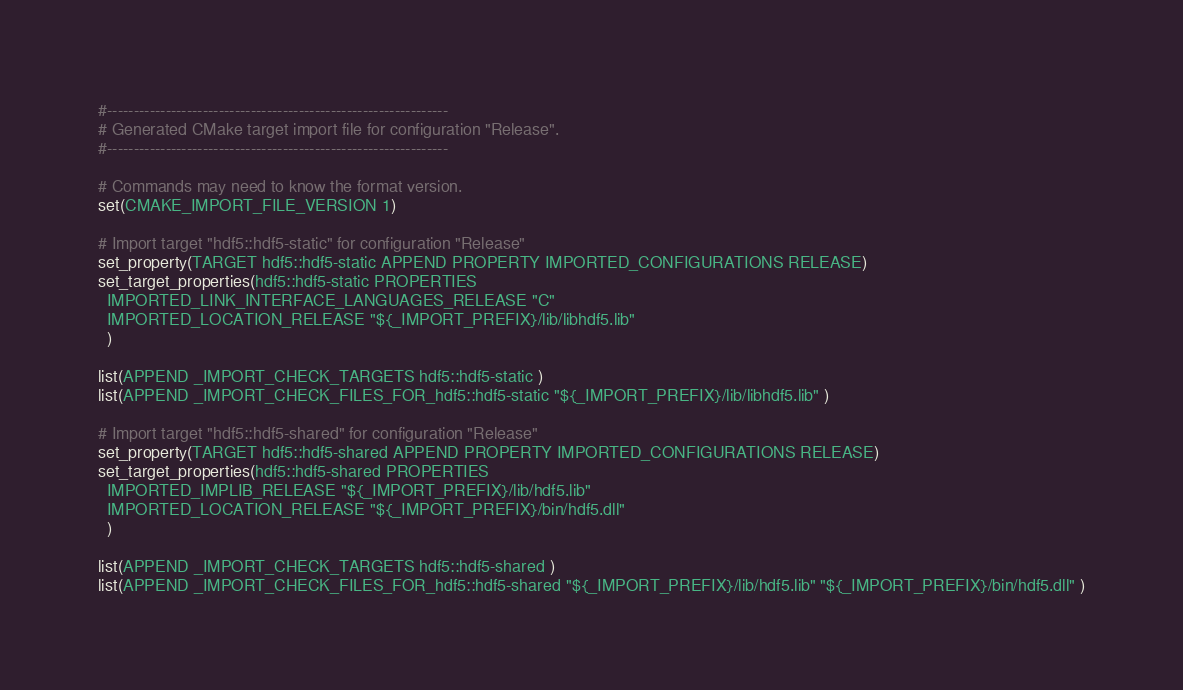Convert code to text. <code><loc_0><loc_0><loc_500><loc_500><_CMake_>#----------------------------------------------------------------
# Generated CMake target import file for configuration "Release".
#----------------------------------------------------------------

# Commands may need to know the format version.
set(CMAKE_IMPORT_FILE_VERSION 1)

# Import target "hdf5::hdf5-static" for configuration "Release"
set_property(TARGET hdf5::hdf5-static APPEND PROPERTY IMPORTED_CONFIGURATIONS RELEASE)
set_target_properties(hdf5::hdf5-static PROPERTIES
  IMPORTED_LINK_INTERFACE_LANGUAGES_RELEASE "C"
  IMPORTED_LOCATION_RELEASE "${_IMPORT_PREFIX}/lib/libhdf5.lib"
  )

list(APPEND _IMPORT_CHECK_TARGETS hdf5::hdf5-static )
list(APPEND _IMPORT_CHECK_FILES_FOR_hdf5::hdf5-static "${_IMPORT_PREFIX}/lib/libhdf5.lib" )

# Import target "hdf5::hdf5-shared" for configuration "Release"
set_property(TARGET hdf5::hdf5-shared APPEND PROPERTY IMPORTED_CONFIGURATIONS RELEASE)
set_target_properties(hdf5::hdf5-shared PROPERTIES
  IMPORTED_IMPLIB_RELEASE "${_IMPORT_PREFIX}/lib/hdf5.lib"
  IMPORTED_LOCATION_RELEASE "${_IMPORT_PREFIX}/bin/hdf5.dll"
  )

list(APPEND _IMPORT_CHECK_TARGETS hdf5::hdf5-shared )
list(APPEND _IMPORT_CHECK_FILES_FOR_hdf5::hdf5-shared "${_IMPORT_PREFIX}/lib/hdf5.lib" "${_IMPORT_PREFIX}/bin/hdf5.dll" )
</code> 